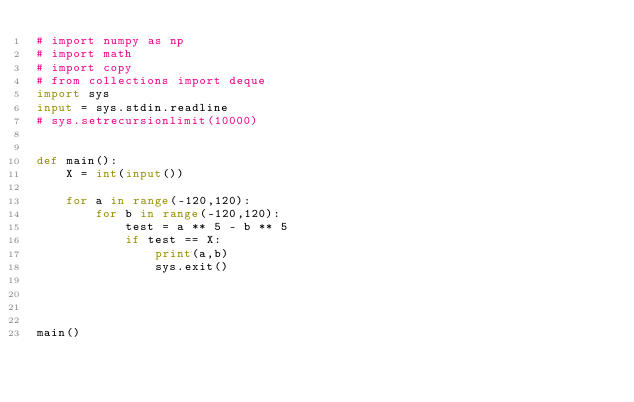Convert code to text. <code><loc_0><loc_0><loc_500><loc_500><_Python_># import numpy as np
# import math
# import copy
# from collections import deque
import sys
input = sys.stdin.readline
# sys.setrecursionlimit(10000)


def main():
    X = int(input())

    for a in range(-120,120):
        for b in range(-120,120):
            test = a ** 5 - b ** 5
            if test == X:
                print(a,b)
                sys.exit()




main()
</code> 